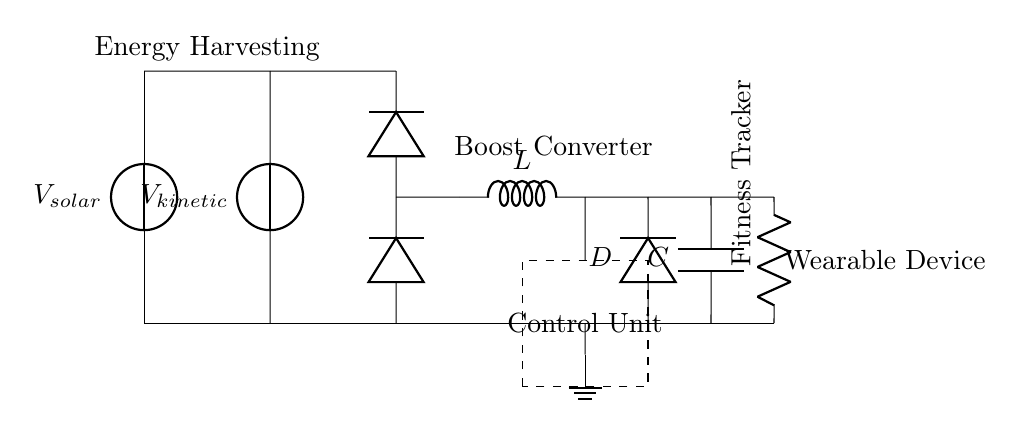What are the two sources of voltage in the circuit? The circuit has two voltage sources: one from the solar cells and another from the kinetic generator. Both sources are represented as voltage symbols in the diagram.
Answer: Solar and kinetic What component is responsible for converting voltage from the solar cell and kinetic energy? A rectifier converts AC voltage from the kinetic generator and maintains a unidirectional flow for the circuit. It is represented by two diode symbols in the diagram, indicating its function in managing current direction.
Answer: Rectifier How many diodes are present in this circuit? There are two diodes in the circuit, both of which are involved in the rectification process. They direct the current from the voltage sources toward the load.
Answer: Two What function does the boost converter have in this system? The boost converter increases the voltage supplied to the fitness tracker, enabling it to operate efficiently despite the possibly lower voltage from the energy harvesting components. It is indicated by the inductor symbol and its connections in the circuit diagram.
Answer: Increase voltage What is the load connected to the circuit? The load connected to the circuit is the fitness tracker, which is represented by a resistor symbol in the diagram. This indicates it is where the electrical energy is used in the system.
Answer: Fitness tracker How is the control unit represented in the circuit? The control unit is shown as a dashed rectangle in the circuit, indicating a section that manages the operation of the energy harvesting system by regulating signals from both energy sources.
Answer: Dashed rectangle 